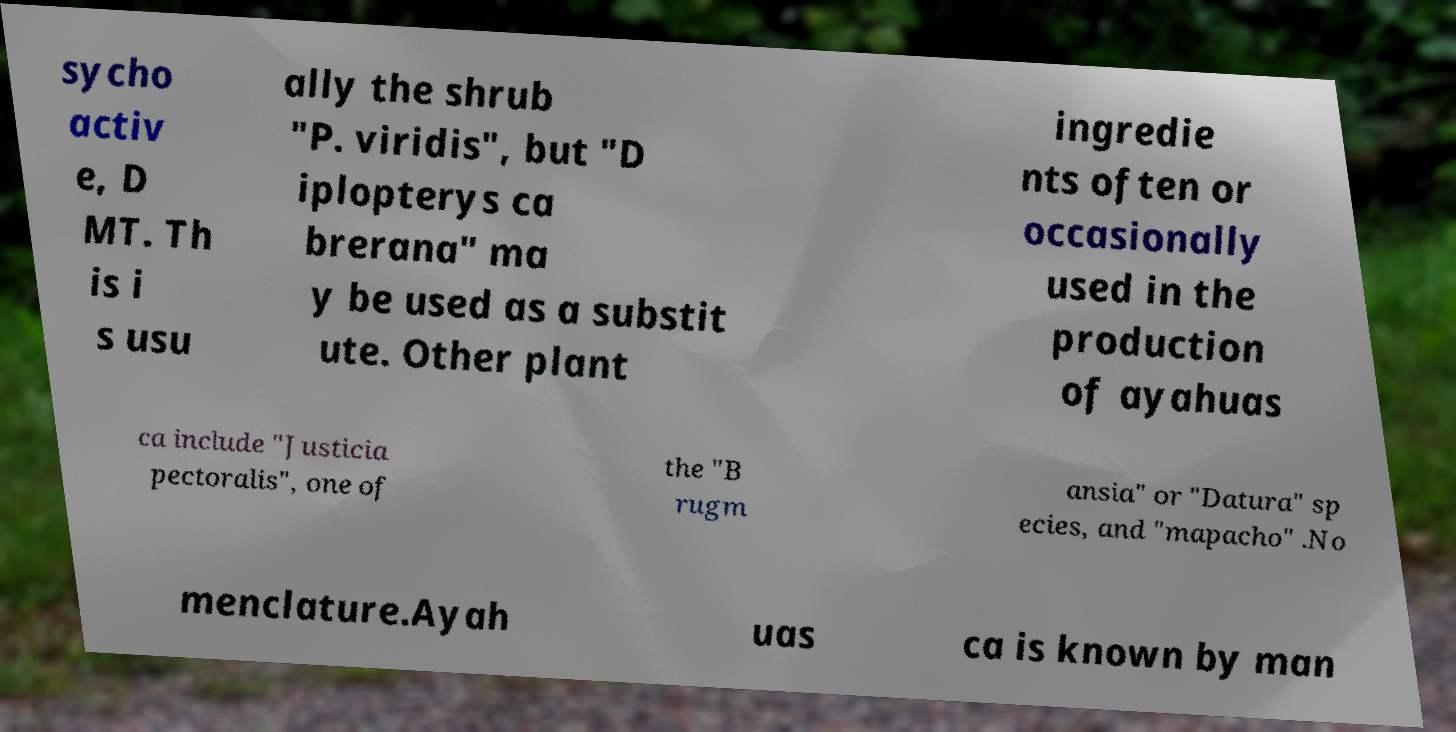Can you read and provide the text displayed in the image?This photo seems to have some interesting text. Can you extract and type it out for me? sycho activ e, D MT. Th is i s usu ally the shrub "P. viridis", but "D iplopterys ca brerana" ma y be used as a substit ute. Other plant ingredie nts often or occasionally used in the production of ayahuas ca include "Justicia pectoralis", one of the "B rugm ansia" or "Datura" sp ecies, and "mapacho" .No menclature.Ayah uas ca is known by man 